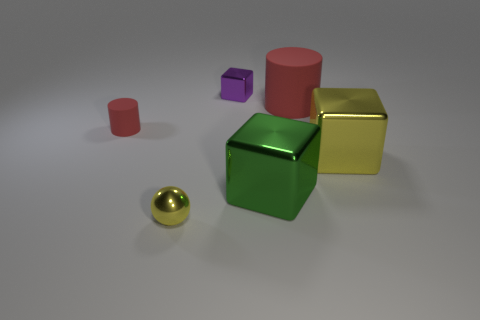Subtract all big metallic blocks. How many blocks are left? 1 Add 4 large gray matte balls. How many objects exist? 10 Subtract all balls. How many objects are left? 5 Subtract all cyan blocks. Subtract all red cylinders. How many blocks are left? 3 Subtract 0 brown cubes. How many objects are left? 6 Subtract all small purple shiny things. Subtract all yellow metal things. How many objects are left? 3 Add 4 large rubber cylinders. How many large rubber cylinders are left? 5 Add 6 gray matte blocks. How many gray matte blocks exist? 6 